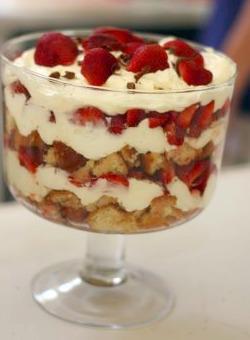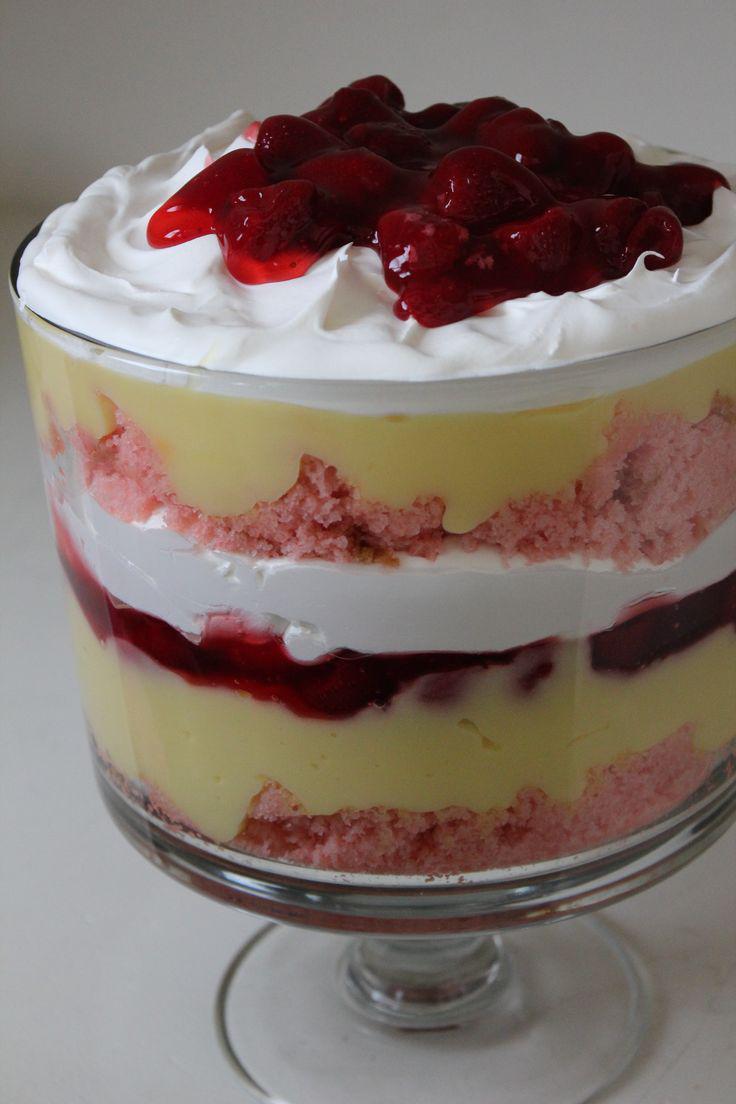The first image is the image on the left, the second image is the image on the right. Analyze the images presented: Is the assertion "there are blueberries on the top of the dessert in one of the images." valid? Answer yes or no. No. The first image is the image on the left, the second image is the image on the right. Examine the images to the left and right. Is the description "Strawberries and blueberries top one of the desserts depicted." accurate? Answer yes or no. No. 